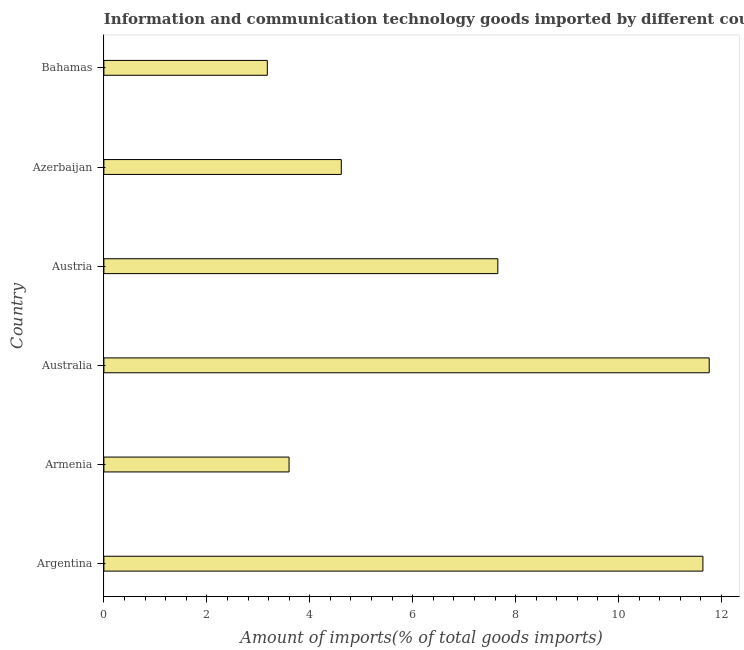Does the graph contain any zero values?
Provide a succinct answer. No. What is the title of the graph?
Your answer should be compact. Information and communication technology goods imported by different countries. What is the label or title of the X-axis?
Your answer should be very brief. Amount of imports(% of total goods imports). What is the amount of ict goods imports in Armenia?
Provide a short and direct response. 3.6. Across all countries, what is the maximum amount of ict goods imports?
Offer a very short reply. 11.76. Across all countries, what is the minimum amount of ict goods imports?
Your answer should be very brief. 3.18. In which country was the amount of ict goods imports minimum?
Ensure brevity in your answer.  Bahamas. What is the sum of the amount of ict goods imports?
Your answer should be very brief. 42.44. What is the difference between the amount of ict goods imports in Azerbaijan and Bahamas?
Ensure brevity in your answer.  1.44. What is the average amount of ict goods imports per country?
Ensure brevity in your answer.  7.07. What is the median amount of ict goods imports?
Your response must be concise. 6.13. What is the ratio of the amount of ict goods imports in Argentina to that in Azerbaijan?
Give a very brief answer. 2.52. Is the amount of ict goods imports in Armenia less than that in Australia?
Make the answer very short. Yes. What is the difference between the highest and the second highest amount of ict goods imports?
Make the answer very short. 0.12. Is the sum of the amount of ict goods imports in Armenia and Australia greater than the maximum amount of ict goods imports across all countries?
Ensure brevity in your answer.  Yes. What is the difference between the highest and the lowest amount of ict goods imports?
Offer a terse response. 8.59. How many bars are there?
Ensure brevity in your answer.  6. Are all the bars in the graph horizontal?
Ensure brevity in your answer.  Yes. What is the difference between two consecutive major ticks on the X-axis?
Your response must be concise. 2. What is the Amount of imports(% of total goods imports) in Argentina?
Keep it short and to the point. 11.64. What is the Amount of imports(% of total goods imports) in Armenia?
Your answer should be very brief. 3.6. What is the Amount of imports(% of total goods imports) of Australia?
Ensure brevity in your answer.  11.76. What is the Amount of imports(% of total goods imports) in Austria?
Your answer should be very brief. 7.65. What is the Amount of imports(% of total goods imports) in Azerbaijan?
Ensure brevity in your answer.  4.61. What is the Amount of imports(% of total goods imports) of Bahamas?
Offer a very short reply. 3.18. What is the difference between the Amount of imports(% of total goods imports) in Argentina and Armenia?
Your answer should be compact. 8.04. What is the difference between the Amount of imports(% of total goods imports) in Argentina and Australia?
Ensure brevity in your answer.  -0.12. What is the difference between the Amount of imports(% of total goods imports) in Argentina and Austria?
Ensure brevity in your answer.  3.98. What is the difference between the Amount of imports(% of total goods imports) in Argentina and Azerbaijan?
Offer a very short reply. 7.03. What is the difference between the Amount of imports(% of total goods imports) in Argentina and Bahamas?
Ensure brevity in your answer.  8.46. What is the difference between the Amount of imports(% of total goods imports) in Armenia and Australia?
Provide a short and direct response. -8.16. What is the difference between the Amount of imports(% of total goods imports) in Armenia and Austria?
Make the answer very short. -4.06. What is the difference between the Amount of imports(% of total goods imports) in Armenia and Azerbaijan?
Provide a succinct answer. -1.01. What is the difference between the Amount of imports(% of total goods imports) in Armenia and Bahamas?
Give a very brief answer. 0.42. What is the difference between the Amount of imports(% of total goods imports) in Australia and Austria?
Keep it short and to the point. 4.11. What is the difference between the Amount of imports(% of total goods imports) in Australia and Azerbaijan?
Your response must be concise. 7.15. What is the difference between the Amount of imports(% of total goods imports) in Australia and Bahamas?
Offer a terse response. 8.59. What is the difference between the Amount of imports(% of total goods imports) in Austria and Azerbaijan?
Your answer should be compact. 3.04. What is the difference between the Amount of imports(% of total goods imports) in Austria and Bahamas?
Give a very brief answer. 4.48. What is the difference between the Amount of imports(% of total goods imports) in Azerbaijan and Bahamas?
Ensure brevity in your answer.  1.44. What is the ratio of the Amount of imports(% of total goods imports) in Argentina to that in Armenia?
Offer a terse response. 3.23. What is the ratio of the Amount of imports(% of total goods imports) in Argentina to that in Australia?
Offer a terse response. 0.99. What is the ratio of the Amount of imports(% of total goods imports) in Argentina to that in Austria?
Ensure brevity in your answer.  1.52. What is the ratio of the Amount of imports(% of total goods imports) in Argentina to that in Azerbaijan?
Offer a terse response. 2.52. What is the ratio of the Amount of imports(% of total goods imports) in Argentina to that in Bahamas?
Give a very brief answer. 3.67. What is the ratio of the Amount of imports(% of total goods imports) in Armenia to that in Australia?
Offer a terse response. 0.31. What is the ratio of the Amount of imports(% of total goods imports) in Armenia to that in Austria?
Your answer should be compact. 0.47. What is the ratio of the Amount of imports(% of total goods imports) in Armenia to that in Azerbaijan?
Keep it short and to the point. 0.78. What is the ratio of the Amount of imports(% of total goods imports) in Armenia to that in Bahamas?
Offer a very short reply. 1.13. What is the ratio of the Amount of imports(% of total goods imports) in Australia to that in Austria?
Offer a terse response. 1.54. What is the ratio of the Amount of imports(% of total goods imports) in Australia to that in Azerbaijan?
Your response must be concise. 2.55. What is the ratio of the Amount of imports(% of total goods imports) in Australia to that in Bahamas?
Offer a very short reply. 3.7. What is the ratio of the Amount of imports(% of total goods imports) in Austria to that in Azerbaijan?
Your response must be concise. 1.66. What is the ratio of the Amount of imports(% of total goods imports) in Austria to that in Bahamas?
Provide a succinct answer. 2.41. What is the ratio of the Amount of imports(% of total goods imports) in Azerbaijan to that in Bahamas?
Provide a short and direct response. 1.45. 